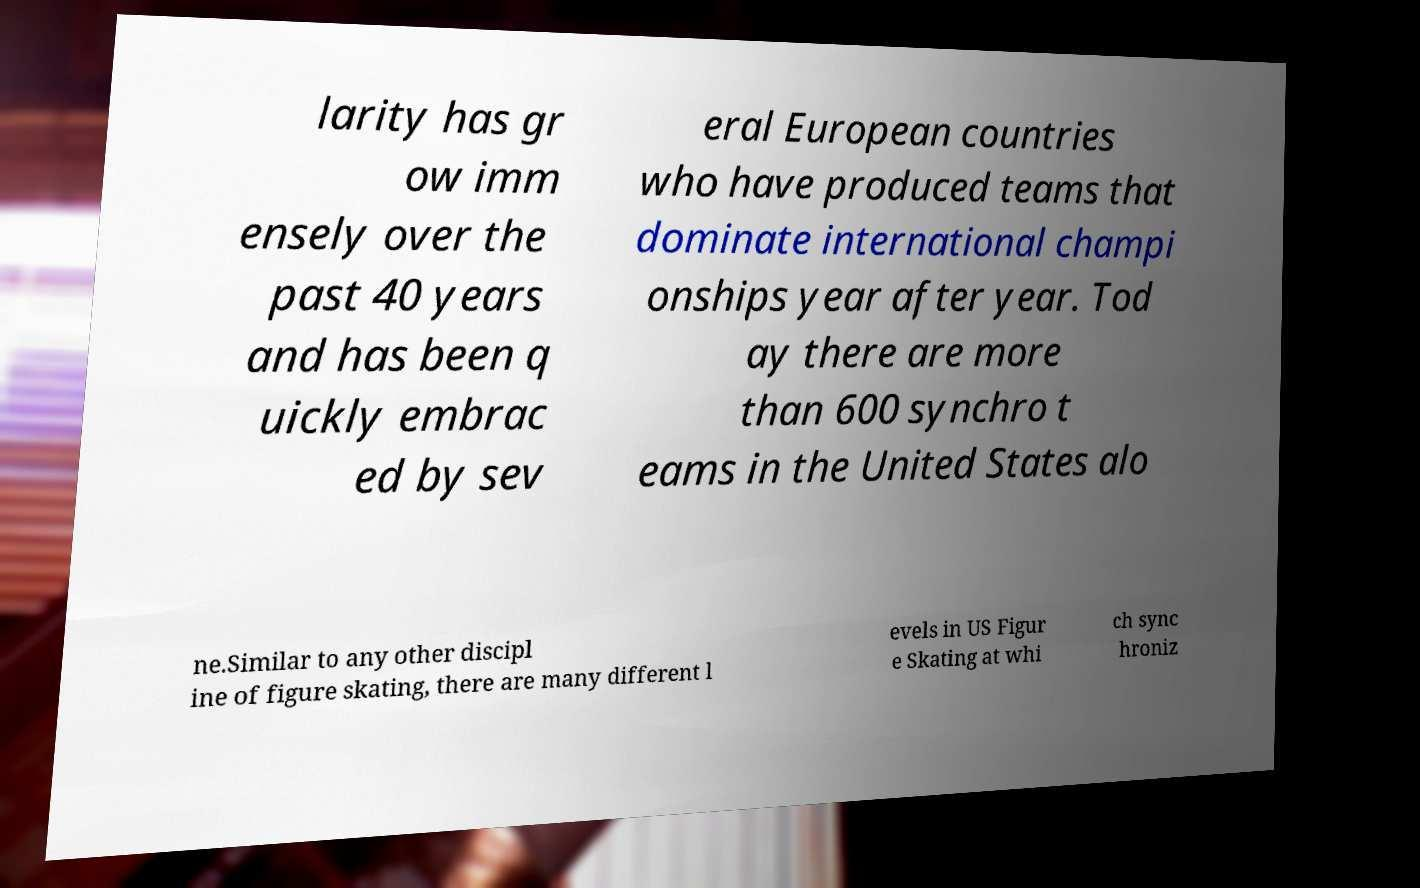Could you assist in decoding the text presented in this image and type it out clearly? larity has gr ow imm ensely over the past 40 years and has been q uickly embrac ed by sev eral European countries who have produced teams that dominate international champi onships year after year. Tod ay there are more than 600 synchro t eams in the United States alo ne.Similar to any other discipl ine of figure skating, there are many different l evels in US Figur e Skating at whi ch sync hroniz 